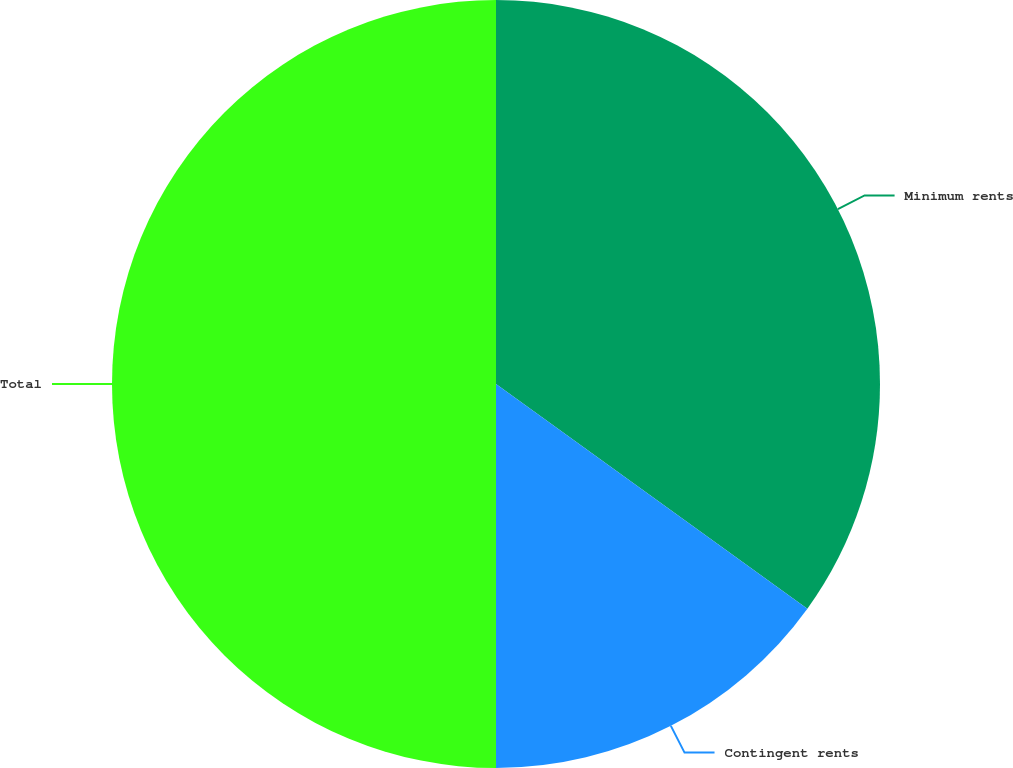Convert chart to OTSL. <chart><loc_0><loc_0><loc_500><loc_500><pie_chart><fcel>Minimum rents<fcel>Contingent rents<fcel>Total<nl><fcel>34.95%<fcel>15.05%<fcel>50.0%<nl></chart> 